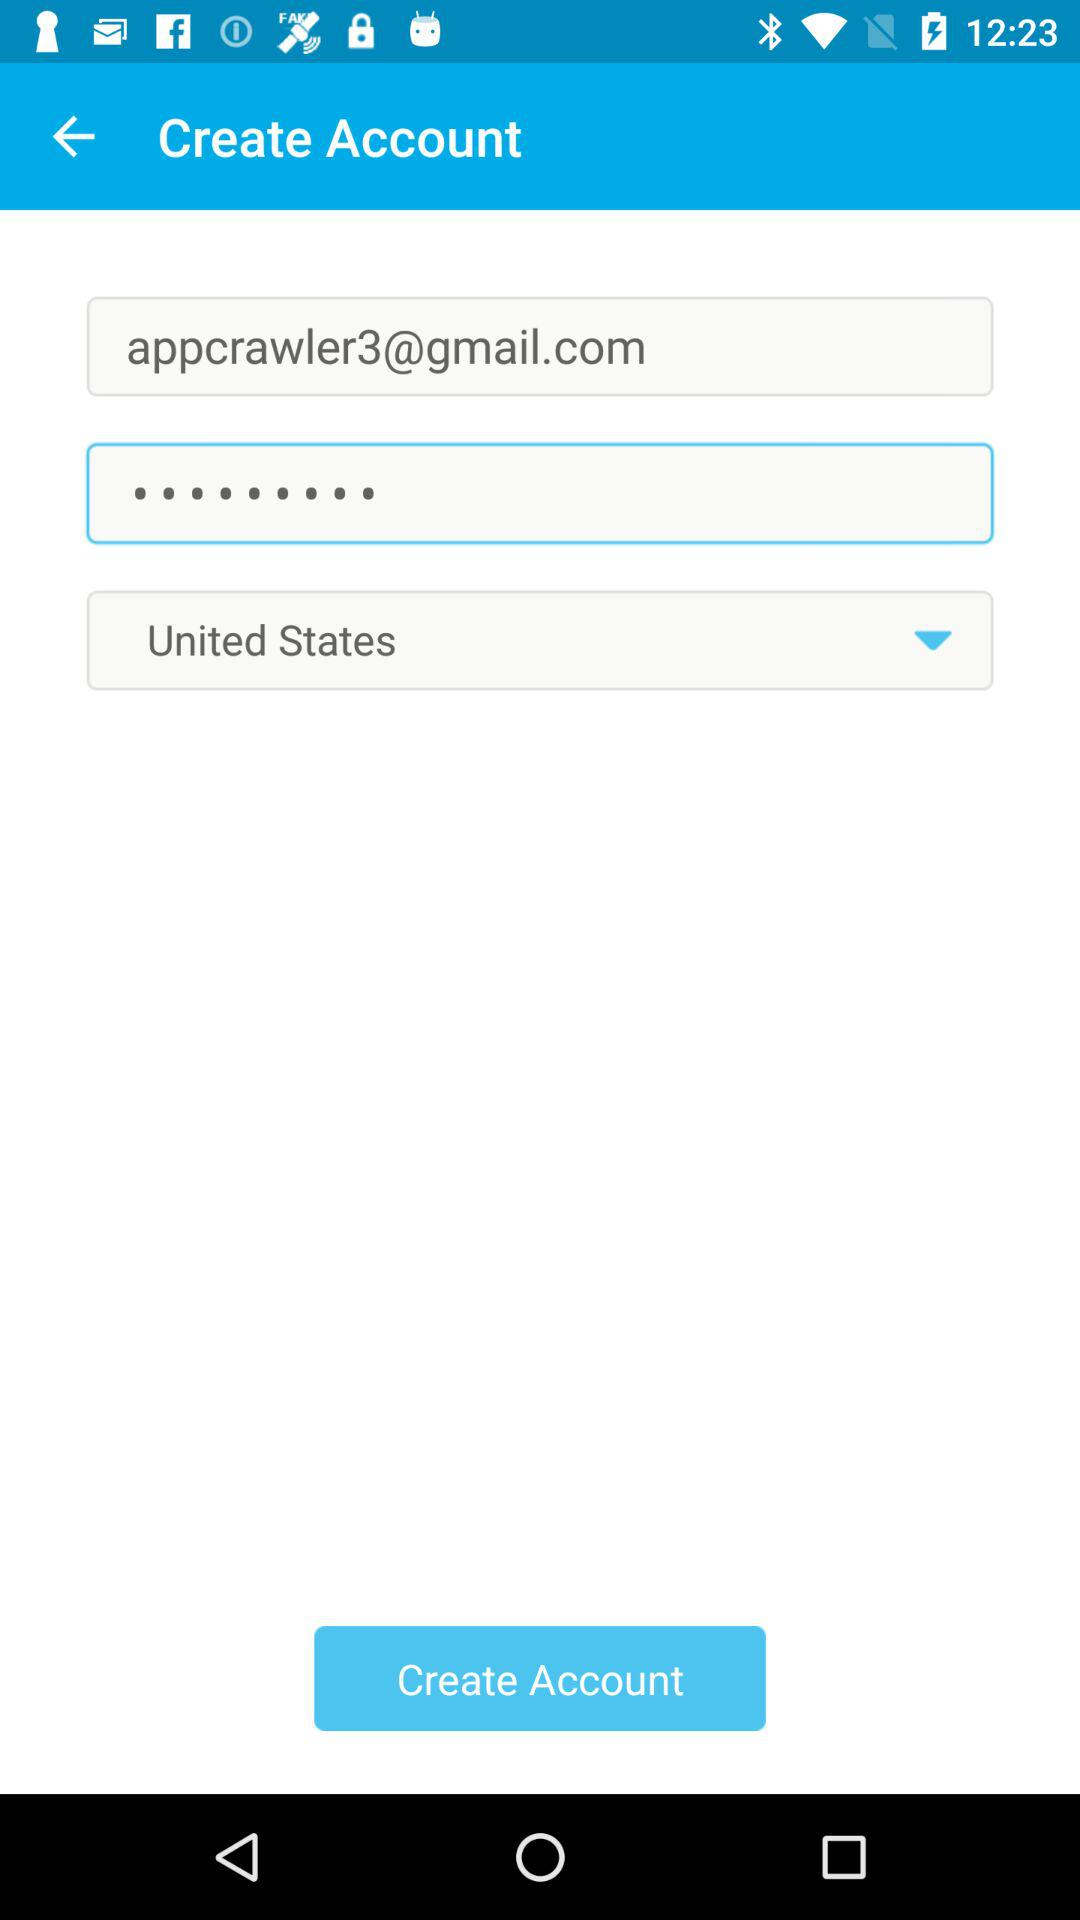How many text inputs are there that are not the country field?
Answer the question using a single word or phrase. 2 